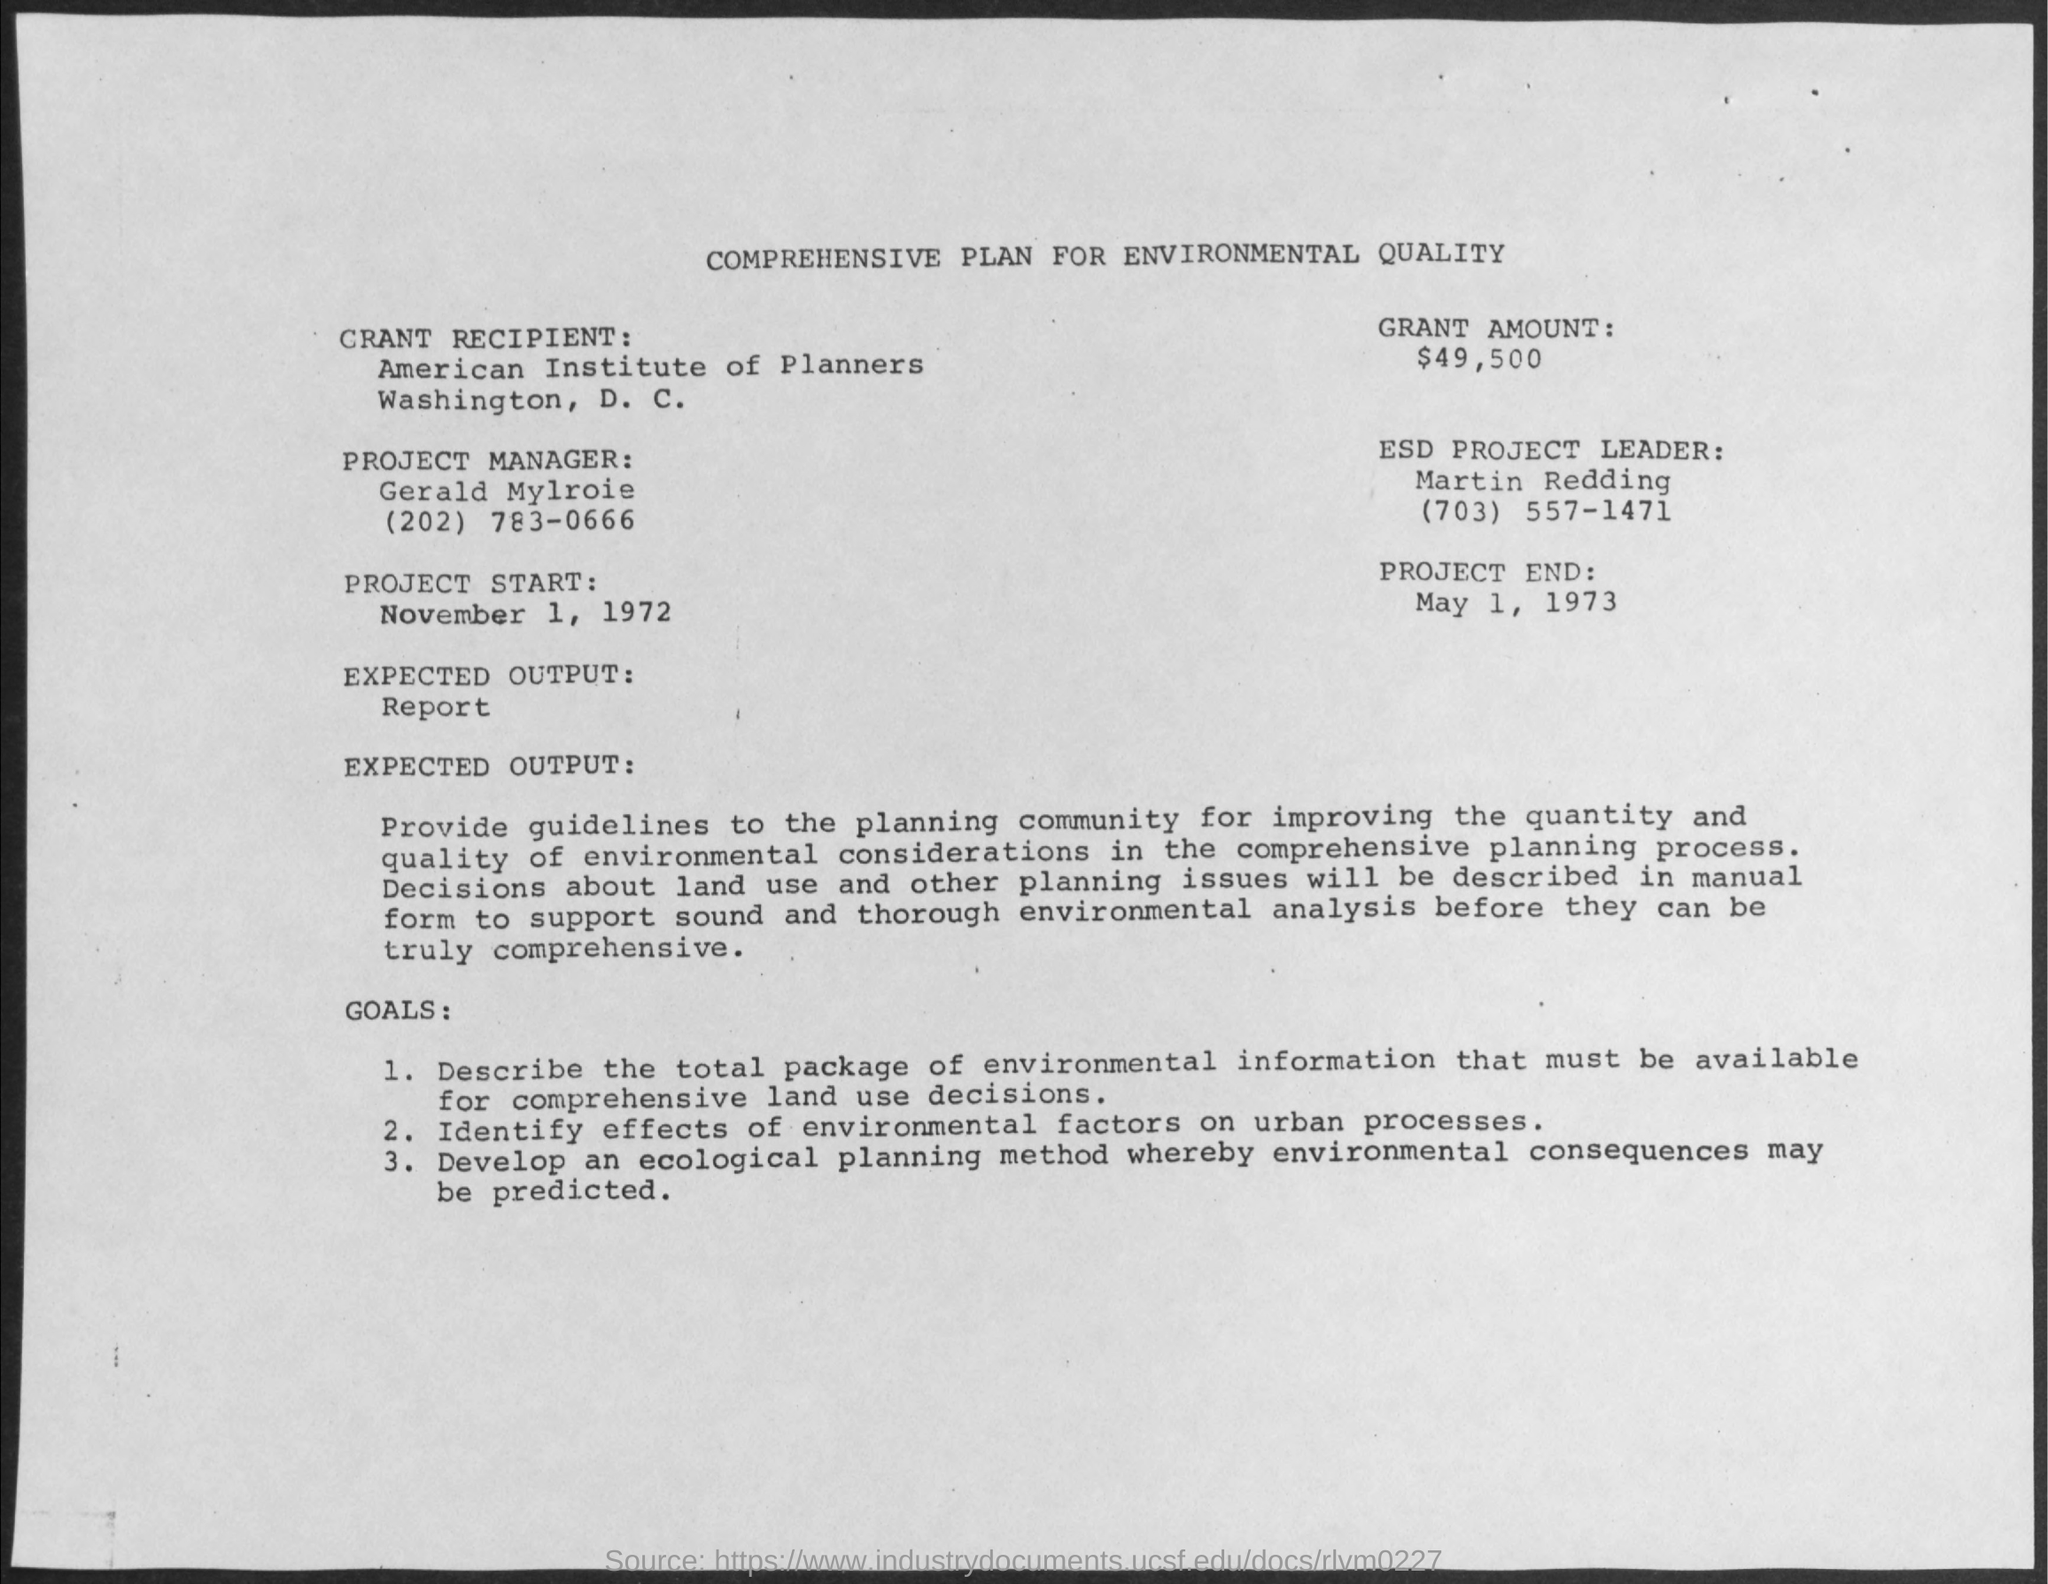What is the name of the project manager given in the plan ?
Ensure brevity in your answer.  Gerald Mylroie. What is the grant amount mentioned in the given plan ?
Your answer should be very brief. $ 49,500. What is the date of project end ?
Your response must be concise. May 1, 1973. What is the name of the esd project leader ?
Your answer should be compact. Martin redding. What  is the date of project start ?
Provide a succinct answer. November 1, 1972. What is the name of the grant recipient ?
Offer a terse response. American Institute of Planners. 